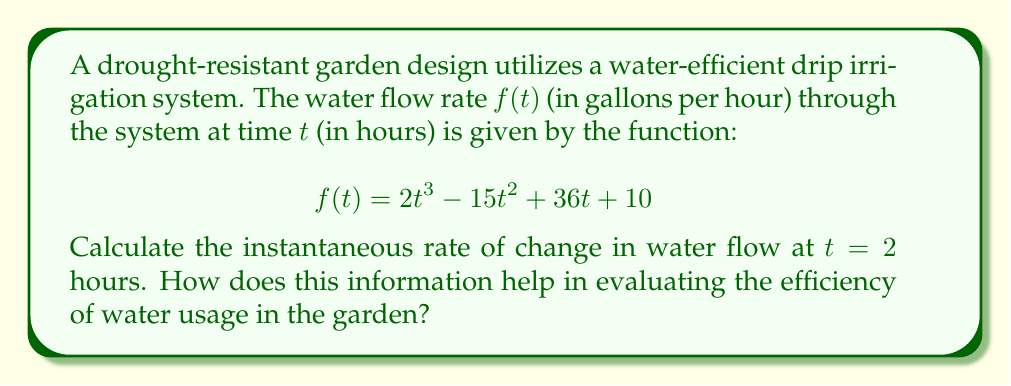Give your solution to this math problem. To find the instantaneous rate of change in water flow at $t = 2$ hours, we need to calculate the derivative of $f(t)$ and evaluate it at $t = 2$.

Step 1: Find the derivative of $f(t)$
$$f(t) = 2t^3 - 15t^2 + 36t + 10$$
$$f'(t) = 6t^2 - 30t + 36$$

Step 2: Evaluate $f'(t)$ at $t = 2$
$$f'(2) = 6(2)^2 - 30(2) + 36$$
$$f'(2) = 6(4) - 60 + 36$$
$$f'(2) = 24 - 60 + 36$$
$$f'(2) = 0$$

The instantaneous rate of change in water flow at $t = 2$ hours is 0 gallons per hour per hour.

This information helps in evaluating the efficiency of water usage in the garden by indicating that at $t = 2$ hours, the water flow rate is neither increasing nor decreasing. This suggests a stable point in the irrigation system's operation, which could be optimal for water conservation. As the garden club president promoting bee-friendly and drought-resistant practices, you can use this information to:

1. Identify the most efficient time to operate the irrigation system.
2. Adjust watering schedules to maintain consistent water flow.
3. Minimize water waste by avoiding periods of rapid flow increase or decrease.
4. Ensure plants receive a steady water supply, promoting healthy growth while conserving water.
Answer: $0$ gallons per hour per hour 